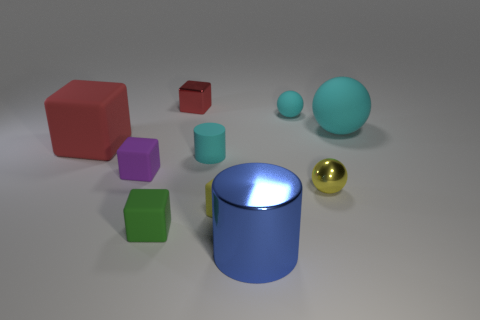There is a large sphere that is the same color as the small cylinder; what is it made of?
Ensure brevity in your answer.  Rubber. Is the color of the metallic cube the same as the big metal cylinder?
Your answer should be very brief. No. Are there any other objects of the same shape as the blue metal object?
Make the answer very short. Yes. What number of green objects are small matte objects or large metallic cylinders?
Provide a short and direct response. 1. Are there any blue things of the same size as the cyan rubber cylinder?
Keep it short and to the point. No. How many yellow rubber blocks are there?
Provide a short and direct response. 1. What number of big objects are either red matte cubes or blue metal cylinders?
Offer a terse response. 2. What color is the cube on the right side of the cyan thing that is to the left of the small yellow object that is in front of the tiny yellow metallic object?
Your response must be concise. Yellow. What number of other objects are there of the same color as the big block?
Keep it short and to the point. 1. What number of metal objects are either blue cylinders or green blocks?
Ensure brevity in your answer.  1. 